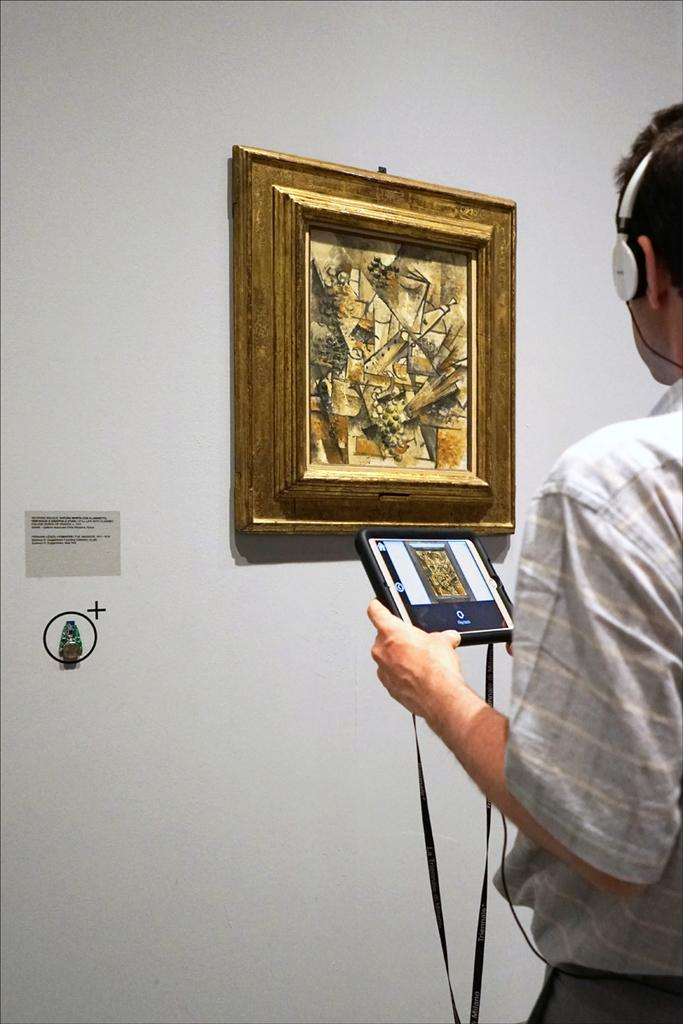Who is the person in the image? There is a man in the image. What is the man wearing on his ears? The man is wearing headphones. What device is the man holding in his hand? The man is holding an iPad in his hand. What can be seen on the wall in the image? There is a photo frame on the wall in the image. What color is the background of the image? The background of the image is white. What month is it in the image? A: The image does not provide any information about the month or time of year. Can you see an airplane in the image? No, there is no airplane present in the image. 